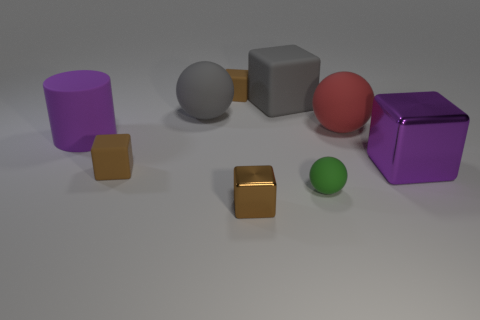Subtract all brown blocks. How many were subtracted if there are1brown blocks left? 2 Subtract all purple cylinders. How many brown cubes are left? 3 Subtract all purple blocks. How many blocks are left? 4 Subtract all cyan blocks. Subtract all gray spheres. How many blocks are left? 5 Subtract all cubes. How many objects are left? 4 Add 4 purple cubes. How many purple cubes are left? 5 Add 1 small green objects. How many small green objects exist? 2 Subtract 0 brown balls. How many objects are left? 9 Subtract all big purple shiny cubes. Subtract all brown things. How many objects are left? 5 